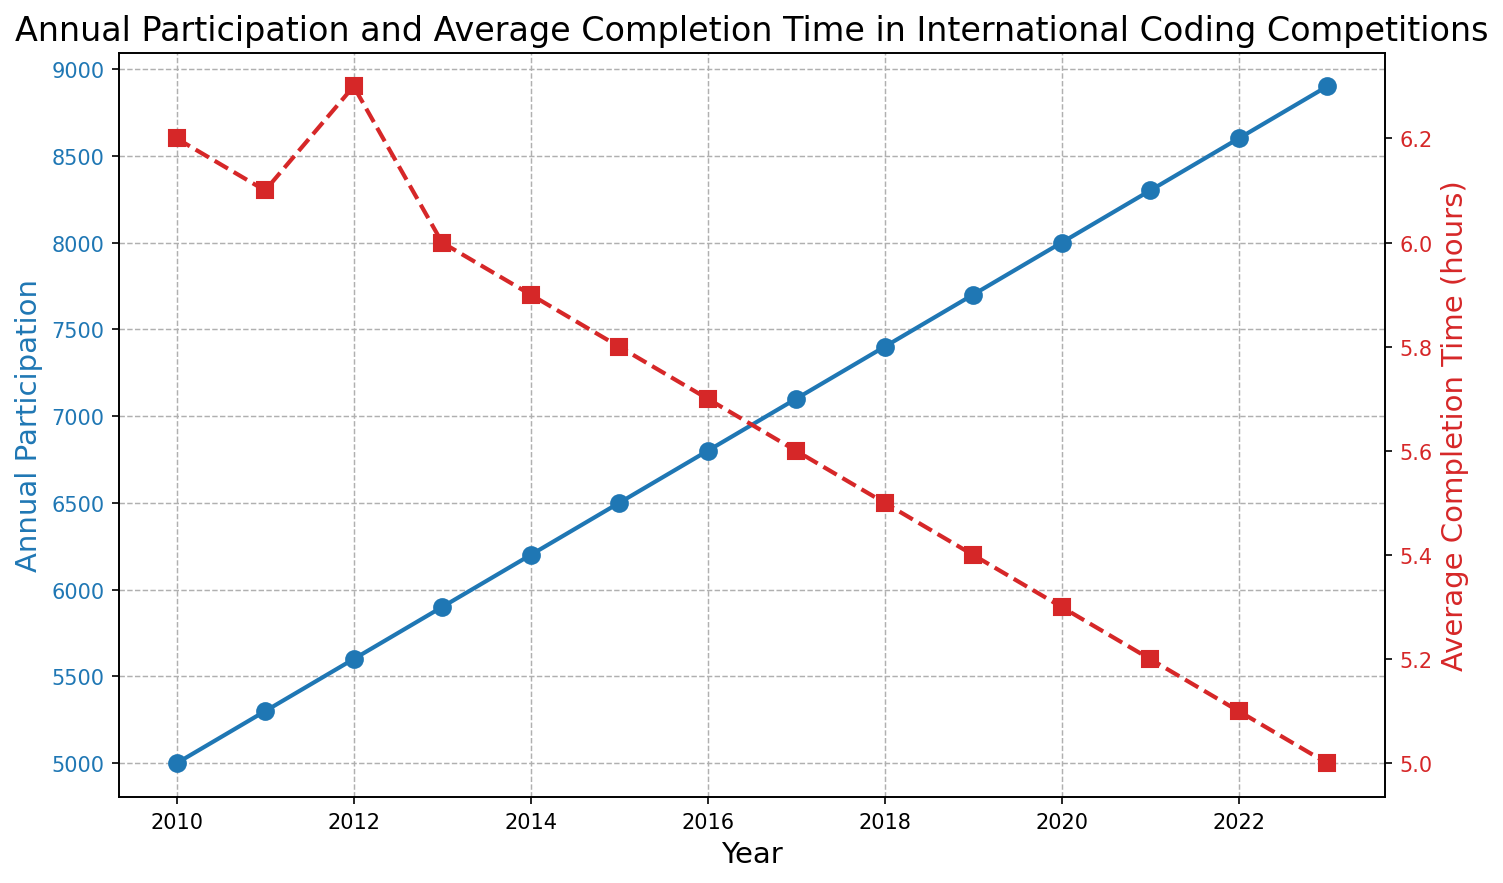What trend in annual participation can be observed from 2010 to 2023? The annual participation appears to increase steadily from 2010 to 2023 as shown by the rising blue line on the primary y-axis.
Answer: Increasing How does the average completion time change from 2010 to 2023? The average completion time decreases from 2010 to 2023, evidenced by the descending red dashed line on the secondary y-axis.
Answer: Decreasing Which year had the highest annual participation? The year 2023 had the highest annual participation, as indicated by the peak of the blue line.
Answer: 2023 What is the difference in average completion time between the years 2010 and 2023? The average completion time in 2010 is 6.2 hours, and in 2023 it is 5.0 hours. The difference is 6.2 - 5.0 = 1.2 hours.
Answer: 1.2 hours Can you spot any year where the annual participation and average completion time trend go in opposite directions? In 2012, annual participation increased while the average completion time also increased slightly.
Answer: 2012 What is the percentage increase in annual participation from 2010 to 2023? The increase in participation is (8900 - 5000) = 3900. The percentage increase is (3900 / 5000) * 100 = 78%.
Answer: 78% What is the average annual participation over the entire period from 2010 to 2023? Sum the annual participation values and divide by the number of years. Sum = 5000 + 5300 + 5600 + 5900 + 6200 + 6500 + 6800 + 7100 + 7400 + 7700 + 8000 + 8300 + 8600 + 8900 = 102300. Average = 102300 / 14 ≈ 7307 participants.
Answer: 7307 participants What is the rate of decrease in average completion time per year from 2010 to 2023? The decrease in average completion time is 6.2 - 5.0 = 1.2 hours over 13 years. Therefore, the rate of decrease is 1.2 / 13 ≈ 0.092 hours per year.
Answer: 0.092 hours/year In what year did the average completion time first drop below 6 hours? The average completion time first dropped below 6 hours in 2013.
Answer: 2013 